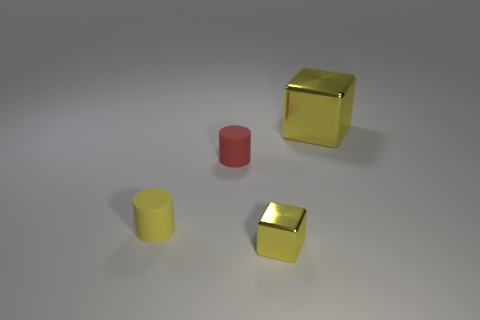Add 3 small objects. How many objects exist? 7 Subtract 0 purple balls. How many objects are left? 4 Subtract all big blue rubber balls. Subtract all large yellow blocks. How many objects are left? 3 Add 3 yellow things. How many yellow things are left? 6 Add 2 yellow matte things. How many yellow matte things exist? 3 